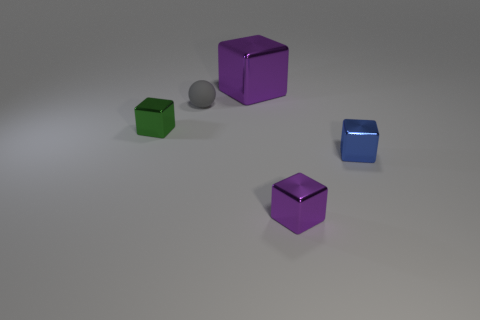Is there anything else that is the same material as the gray object?
Keep it short and to the point. No. What shape is the purple metal object that is behind the purple object that is in front of the blue shiny object?
Your answer should be very brief. Cube. What is the size of the other thing that is the same color as the big thing?
Your answer should be very brief. Small. Are there any blue cubes made of the same material as the green thing?
Keep it short and to the point. Yes. What is the small purple cube right of the gray matte thing made of?
Your answer should be very brief. Metal. What is the tiny gray ball made of?
Provide a short and direct response. Rubber. Do the thing that is behind the small gray thing and the blue object have the same material?
Give a very brief answer. Yes. Are there fewer small gray matte spheres behind the rubber sphere than tiny purple things?
Provide a succinct answer. Yes. The matte ball that is the same size as the blue thing is what color?
Make the answer very short. Gray. How many other tiny objects are the same shape as the green metallic thing?
Provide a short and direct response. 2. 